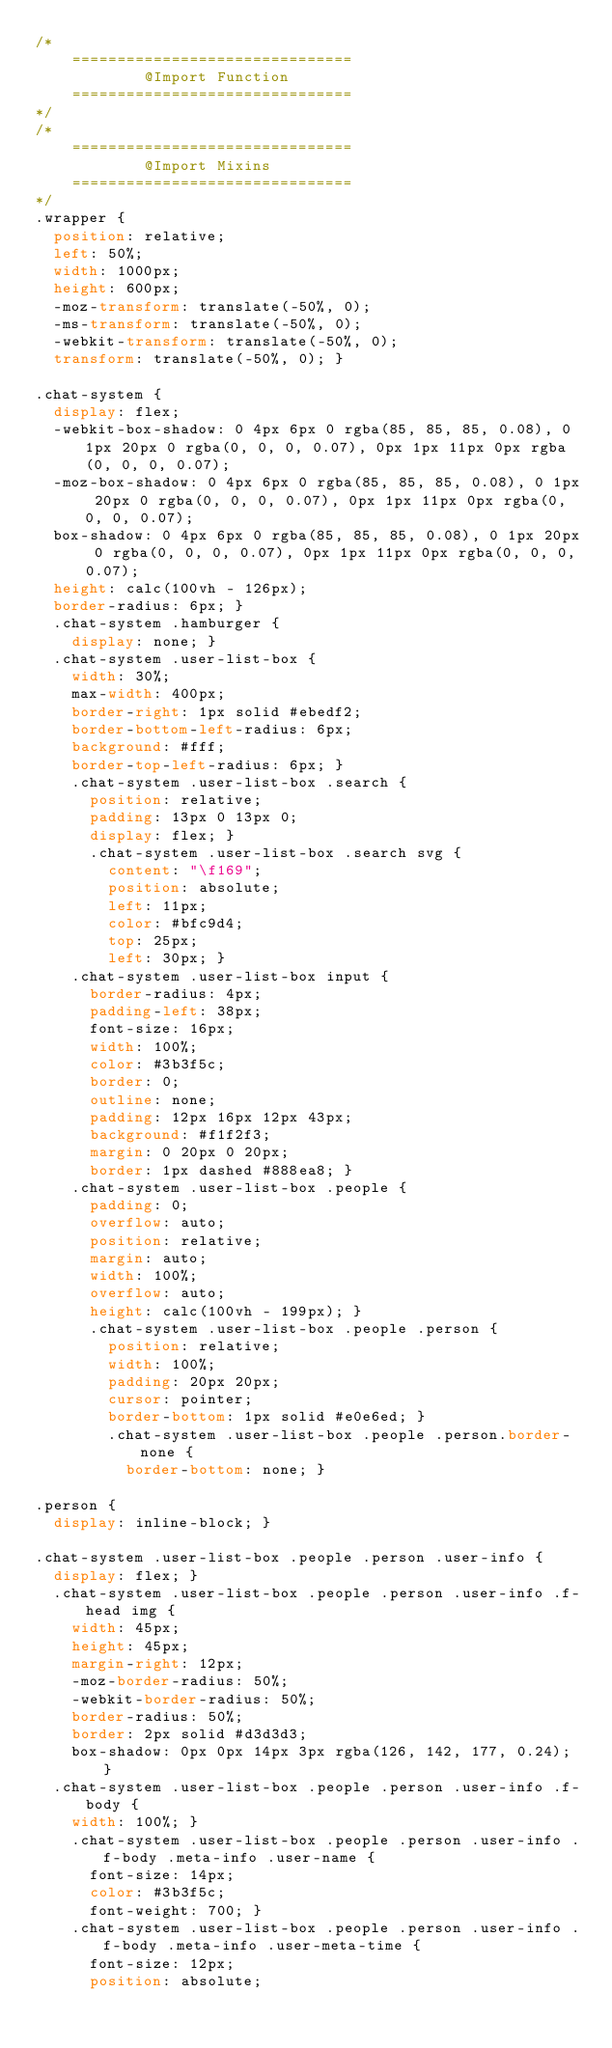<code> <loc_0><loc_0><loc_500><loc_500><_CSS_>/*
	===============================
			@Import	Function
	===============================
*/
/*
	===============================
			@Import	Mixins
	===============================
*/
.wrapper {
  position: relative;
  left: 50%;
  width: 1000px;
  height: 600px;
  -moz-transform: translate(-50%, 0);
  -ms-transform: translate(-50%, 0);
  -webkit-transform: translate(-50%, 0);
  transform: translate(-50%, 0); }

.chat-system {
  display: flex;
  -webkit-box-shadow: 0 4px 6px 0 rgba(85, 85, 85, 0.08), 0 1px 20px 0 rgba(0, 0, 0, 0.07), 0px 1px 11px 0px rgba(0, 0, 0, 0.07);
  -moz-box-shadow: 0 4px 6px 0 rgba(85, 85, 85, 0.08), 0 1px 20px 0 rgba(0, 0, 0, 0.07), 0px 1px 11px 0px rgba(0, 0, 0, 0.07);
  box-shadow: 0 4px 6px 0 rgba(85, 85, 85, 0.08), 0 1px 20px 0 rgba(0, 0, 0, 0.07), 0px 1px 11px 0px rgba(0, 0, 0, 0.07);
  height: calc(100vh - 126px);
  border-radius: 6px; }
  .chat-system .hamburger {
    display: none; }
  .chat-system .user-list-box {
    width: 30%;
    max-width: 400px;
    border-right: 1px solid #ebedf2;
    border-bottom-left-radius: 6px;
    background: #fff;
    border-top-left-radius: 6px; }
    .chat-system .user-list-box .search {
      position: relative;
      padding: 13px 0 13px 0;
      display: flex; }
      .chat-system .user-list-box .search svg {
        content: "\f169";
        position: absolute;
        left: 11px;
        color: #bfc9d4;
        top: 25px;
        left: 30px; }
    .chat-system .user-list-box input {
      border-radius: 4px;
      padding-left: 38px;
      font-size: 16px;
      width: 100%;
      color: #3b3f5c;
      border: 0;
      outline: none;
      padding: 12px 16px 12px 43px;
      background: #f1f2f3;
      margin: 0 20px 0 20px;
      border: 1px dashed #888ea8; }
    .chat-system .user-list-box .people {
      padding: 0;
      overflow: auto;
      position: relative;
      margin: auto;
      width: 100%;
      overflow: auto;
      height: calc(100vh - 199px); }
      .chat-system .user-list-box .people .person {
        position: relative;
        width: 100%;
        padding: 20px 20px;
        cursor: pointer;
        border-bottom: 1px solid #e0e6ed; }
        .chat-system .user-list-box .people .person.border-none {
          border-bottom: none; }

.person {
  display: inline-block; }

.chat-system .user-list-box .people .person .user-info {
  display: flex; }
  .chat-system .user-list-box .people .person .user-info .f-head img {
    width: 45px;
    height: 45px;
    margin-right: 12px;
    -moz-border-radius: 50%;
    -webkit-border-radius: 50%;
    border-radius: 50%;
    border: 2px solid #d3d3d3;
    box-shadow: 0px 0px 14px 3px rgba(126, 142, 177, 0.24); }
  .chat-system .user-list-box .people .person .user-info .f-body {
    width: 100%; }
    .chat-system .user-list-box .people .person .user-info .f-body .meta-info .user-name {
      font-size: 14px;
      color: #3b3f5c;
      font-weight: 700; }
    .chat-system .user-list-box .people .person .user-info .f-body .meta-info .user-meta-time {
      font-size: 12px;
      position: absolute;</code> 